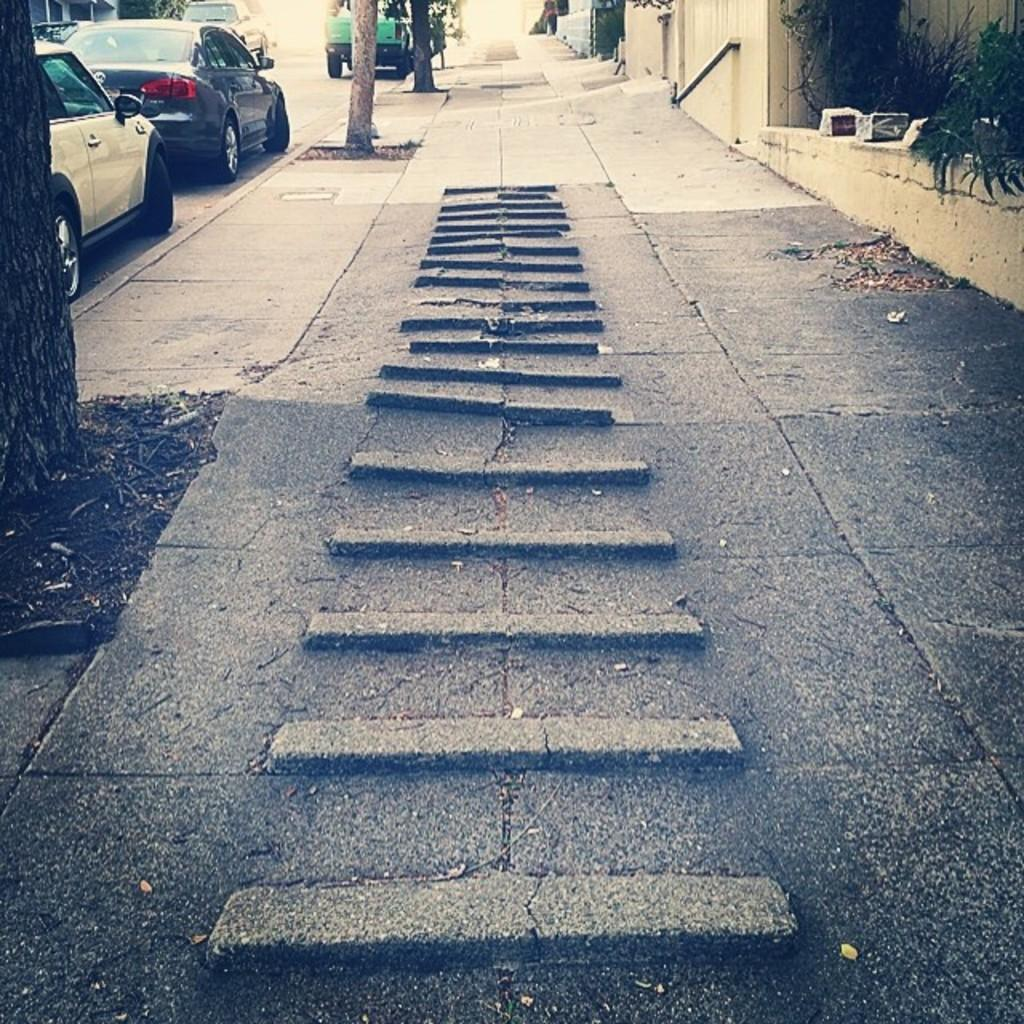What type of pathway is visible in the image? There is a walkway in the image. What can be seen alongside the walkway? There are trees with visible trunks on the side of the road. What type of vehicles are present on the road? Cars are present on the road. Where are the cars located in the image? The cars are located on the top left side of the image. What type of ball is being used to measure the distance between the trees in the image? There is no ball present in the image, nor is there any indication of measuring the distance between trees. 